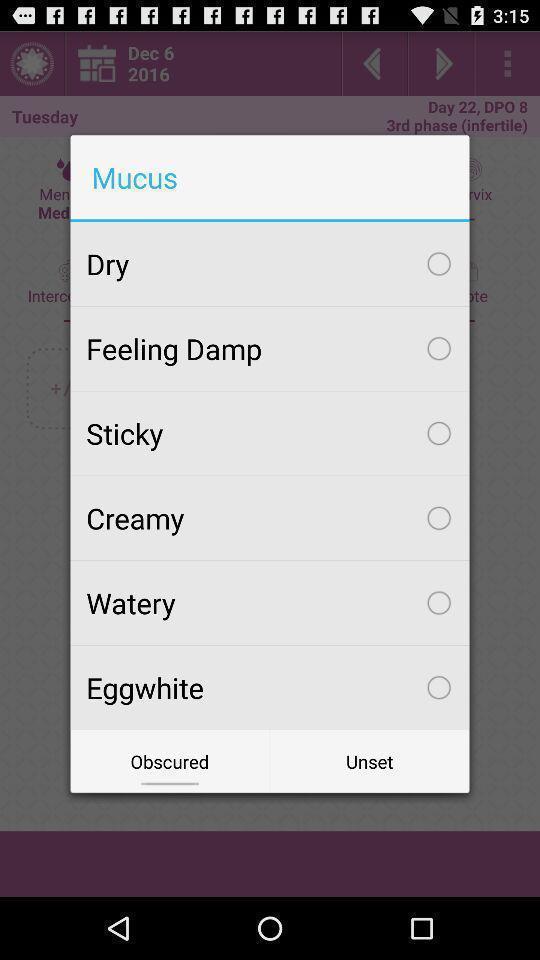Tell me about the visual elements in this screen capture. Push up displaying list of mucus. 